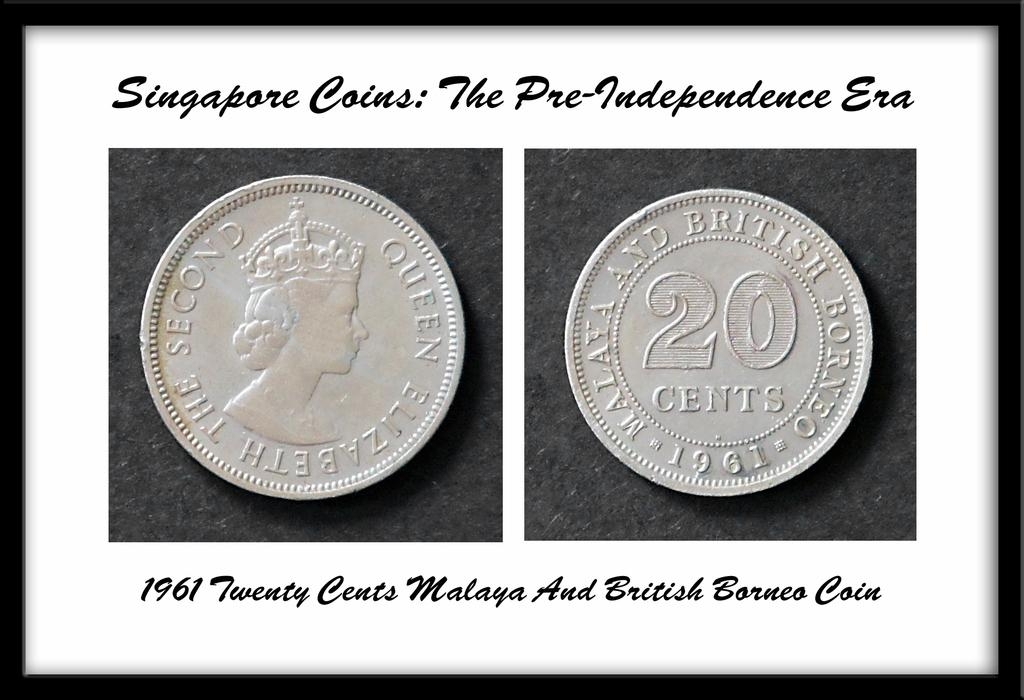<image>
Write a terse but informative summary of the picture. The framed Singapore coins are from the pre independence era. 